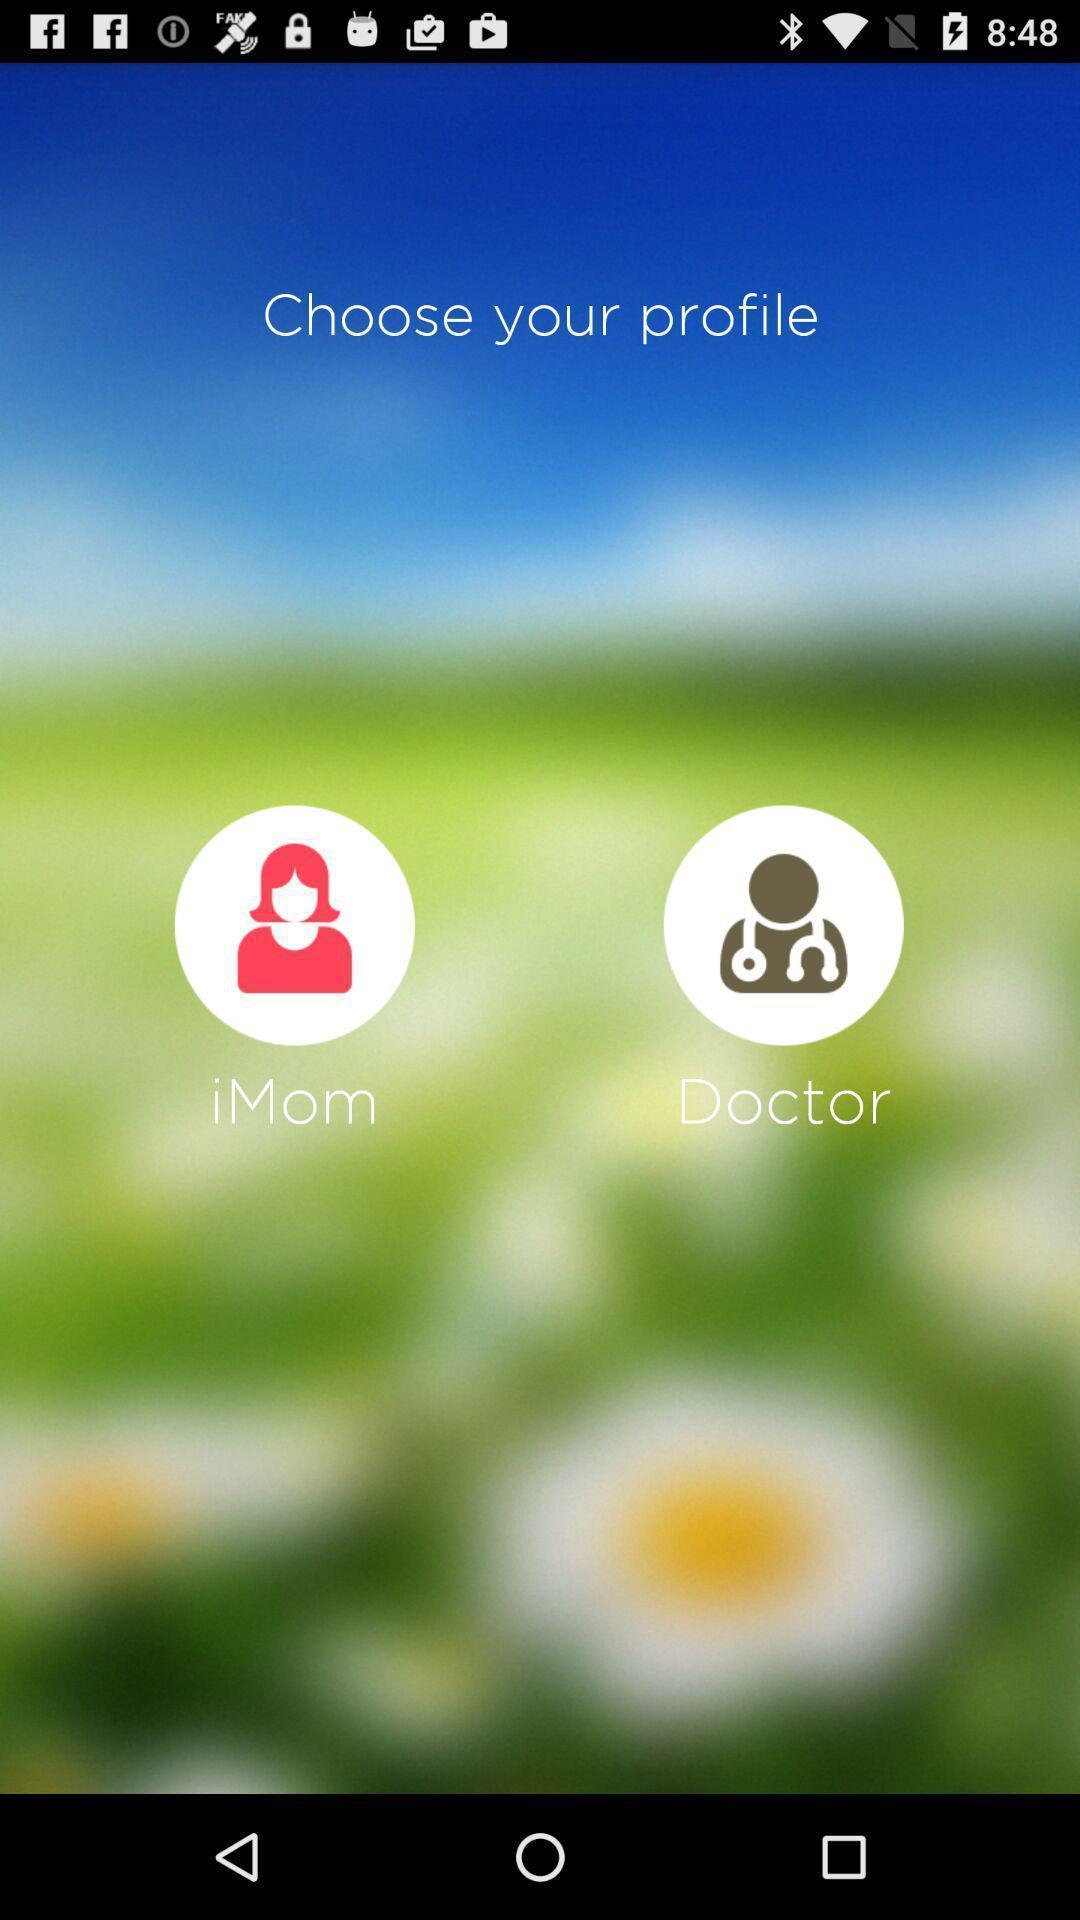Describe this image in words. Screen shows choose profile in a medical app. 